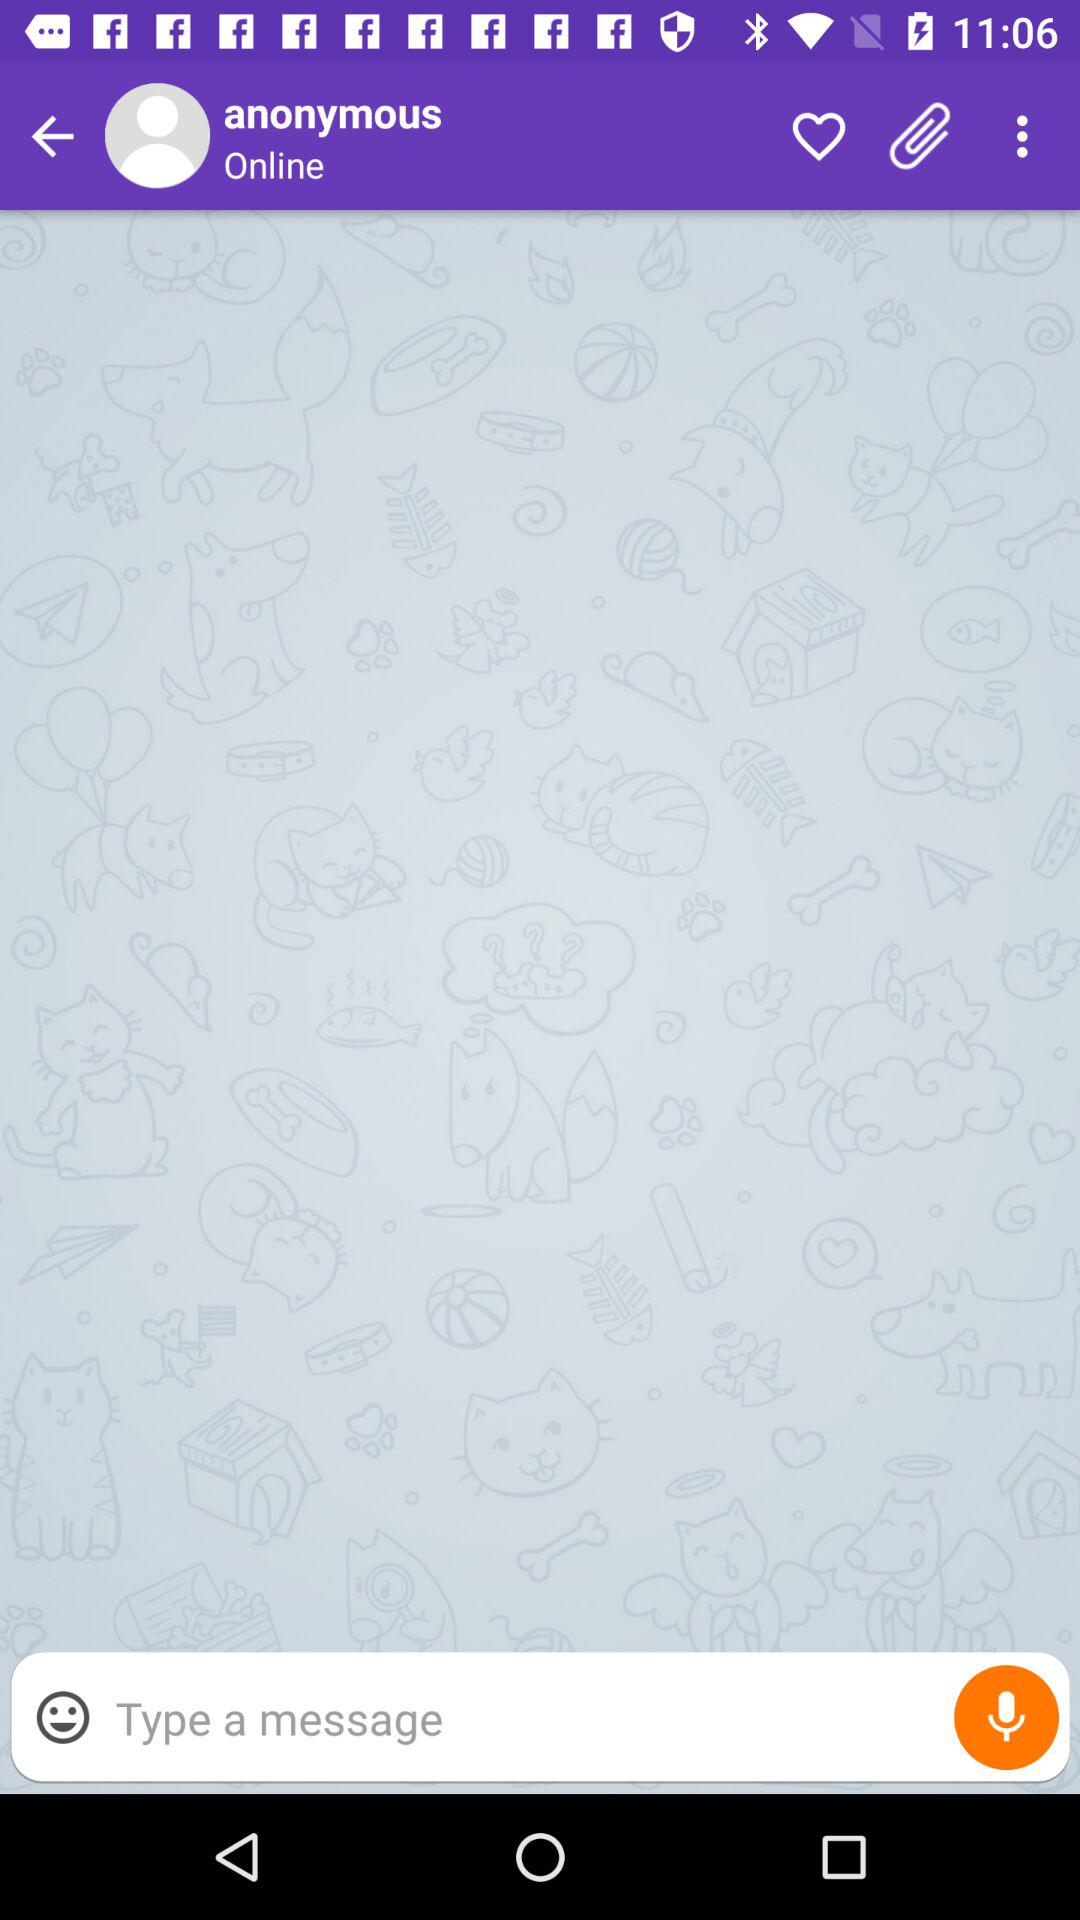Is the user online or not? The user is online. 